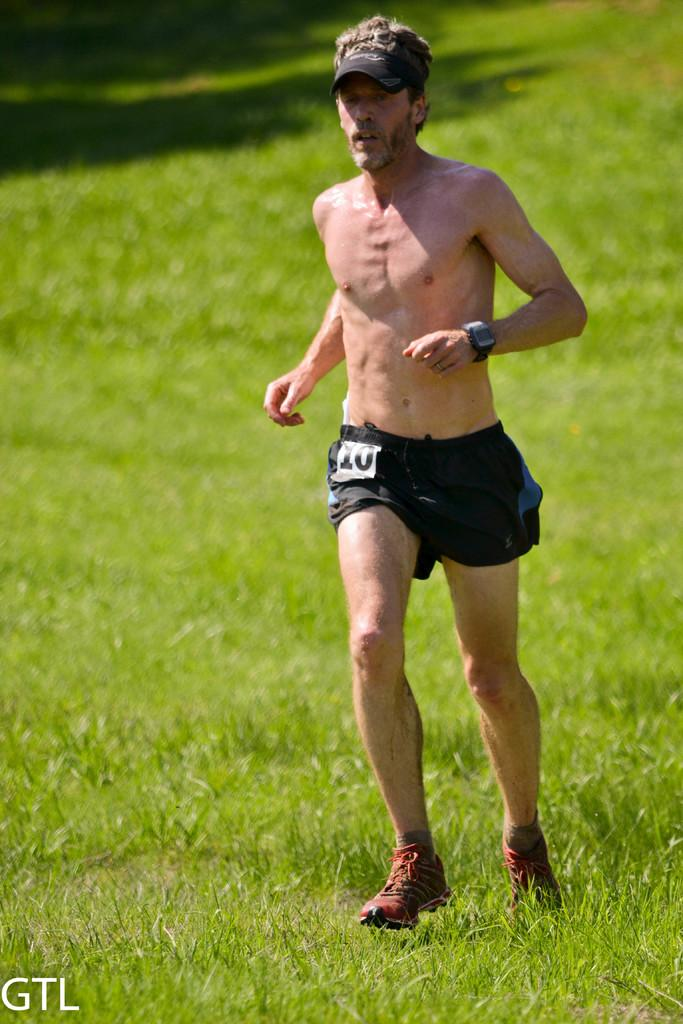What is the main subject of the image? There is a person in the image. What is the person doing in the image? The person is running on the grass. What accessories is the person wearing in the image? The person is wearing a cap and a watch. Is there any text or marking at the bottom of the image? Yes, there is a watermark at the bottom of the image. How many cherries are being held by the cats in the image? There are no cherries or cats present in the image. What type of loaf is being prepared by the person in the image? There is no loaf or indication of food preparation in the image; the person is running on the grass. 